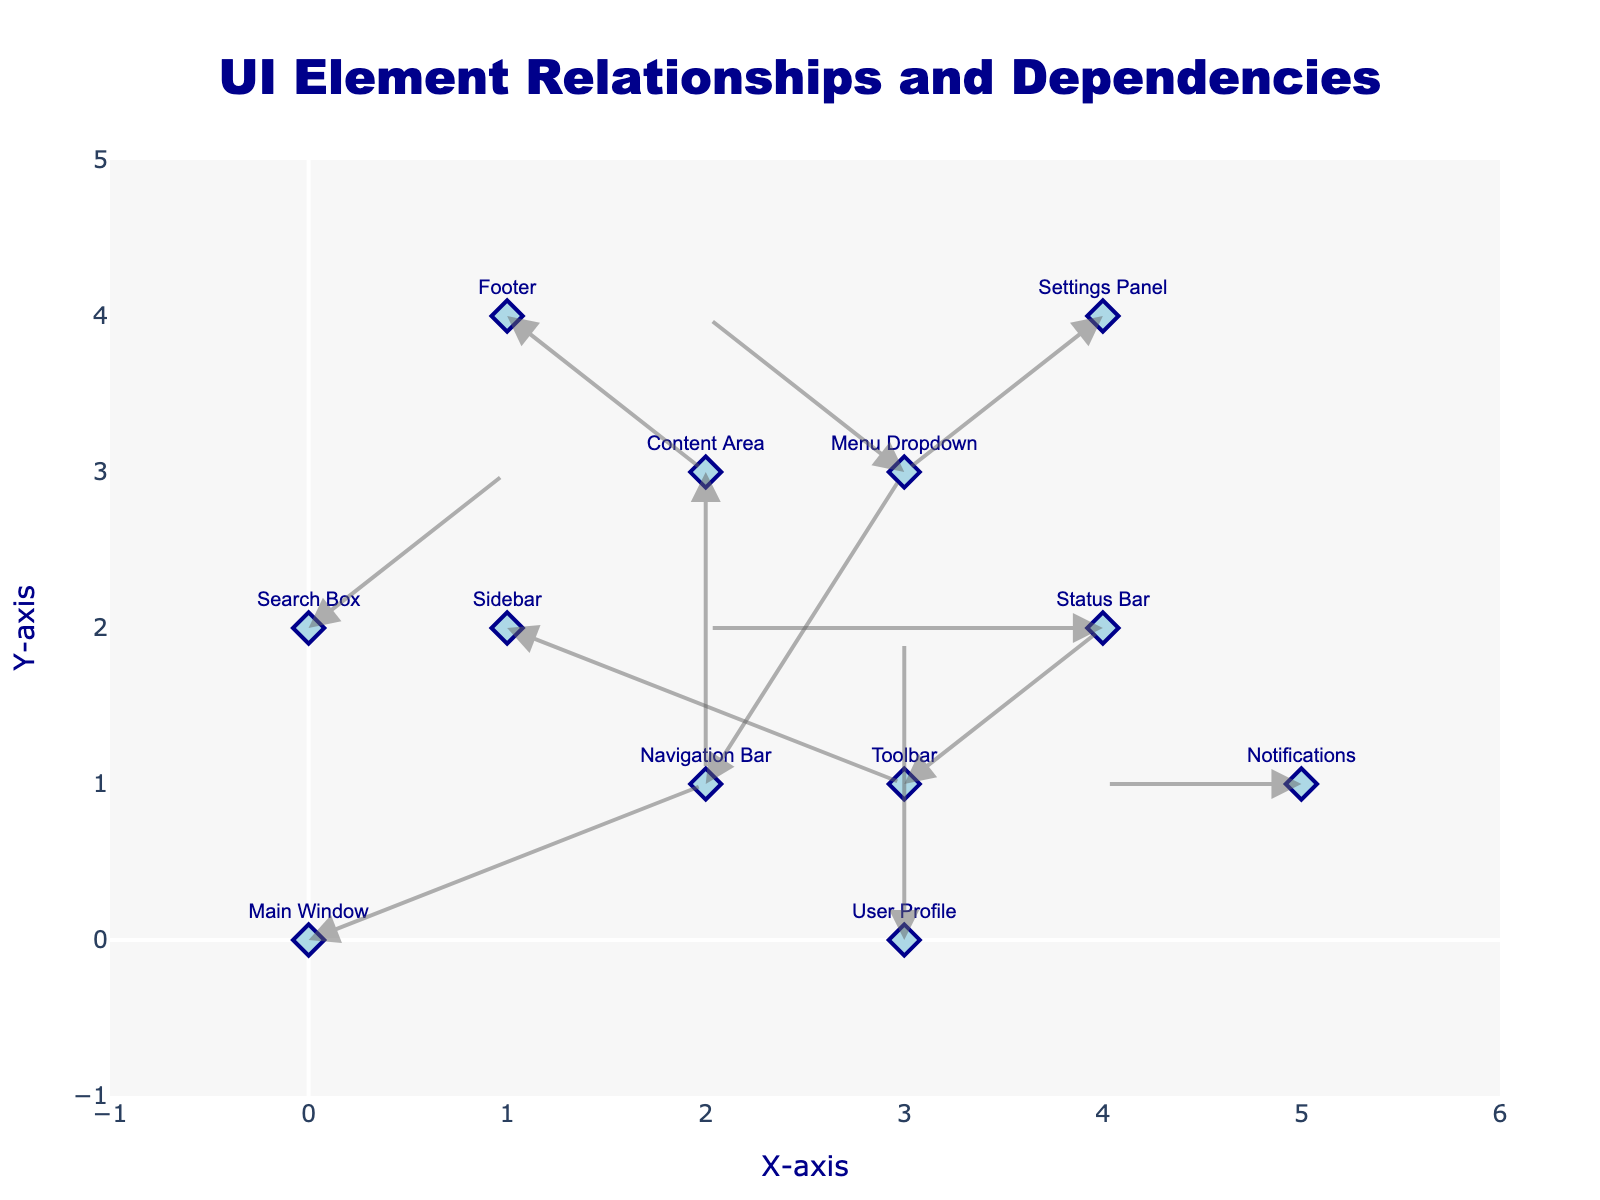what is the title of the figure? The title text is located at the center-top of the figure and reads 'UI Element Relationships and Dependencies'.
Answer: UI Element Relationships and Dependencies How many UI elements are displayed on the graph? There is one marker with text for each UI element in the plot. Counting them, we have 12 UI elements.
Answer: 12 What UI element is located at the (0,0) coordinate? The (0,0) coordinate marker has the label 'Main Window'.
Answer: Main Window Which UI element is directly influenced by the 'Sidebar'? The arrow originating from 'Sidebar' (1,2) points to the coordinate (3,1), which has the label 'Toolbar'.
Answer: Toolbar How many UI elements are affected by the 'Content Area'? There is one arrow originating from 'Content Area' at (2,3), pointing to (2,1), the 'Navigation Bar'.
Answer: 1 What is the new position of the 'Menu Dropdown' after following its direction vector? 'Menu Dropdown' starts at the coordinates (3,3). Moving in its direction vector (-1,1) shifts it to (2,4).
Answer: (2,4) Which elements are connected to the 'Status Bar' and the 'Settings Panel'? The arrow from 'Status Bar' at (4,2) points to (2,2) which is not a labeled UI element. The 'Settings Panel' at (4,4) has no arrows connected to it.
Answer: 'Status Bar': none, 'Settings Panel': none What is the combined horizontal shift from 'Main Window' to 'Navigation Bar' and then to 'Toolbar'? From 'Main Window' (0,0) to 'Navigation Bar' (2,1) shifts +2 horizontally. From 'Navigation Bar' (2,1) to 'Toolbar' (3,1) shifts +1 horizontally. The combined horizontal shift is 2 + 1 = 3.
Answer: 3 Which UI element moves the furthest distance? The furthest distance is the element that has the longest vector. 'Navigation Bar' (2,1) moves to (3,3). The distance is √(1^2+2^2) = √5 ≈ 2.24, the longest one compared to others.
Answer: Navigation Bar 